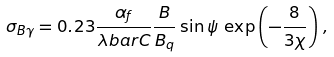Convert formula to latex. <formula><loc_0><loc_0><loc_500><loc_500>\sigma _ { B \gamma } = 0 . 2 3 \frac { \alpha _ { f } } { \lambda b a r C } \frac { B } { B _ { q } } \sin \psi \, \exp \left ( - \frac { 8 } { 3 \chi } \right ) \, ,</formula> 